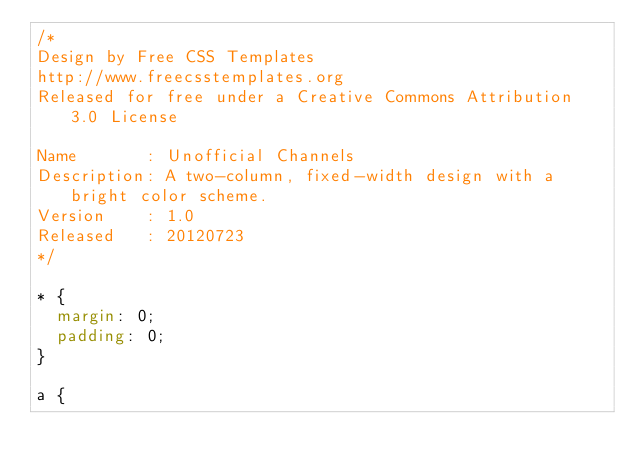Convert code to text. <code><loc_0><loc_0><loc_500><loc_500><_CSS_>/*
Design by Free CSS Templates
http://www.freecsstemplates.org
Released for free under a Creative Commons Attribution 3.0 License

Name       : Unofficial Channels
Description: A two-column, fixed-width design with a bright color scheme.
Version    : 1.0
Released   : 20120723
*/

* {
	margin: 0;
	padding: 0;
}

a {</code> 